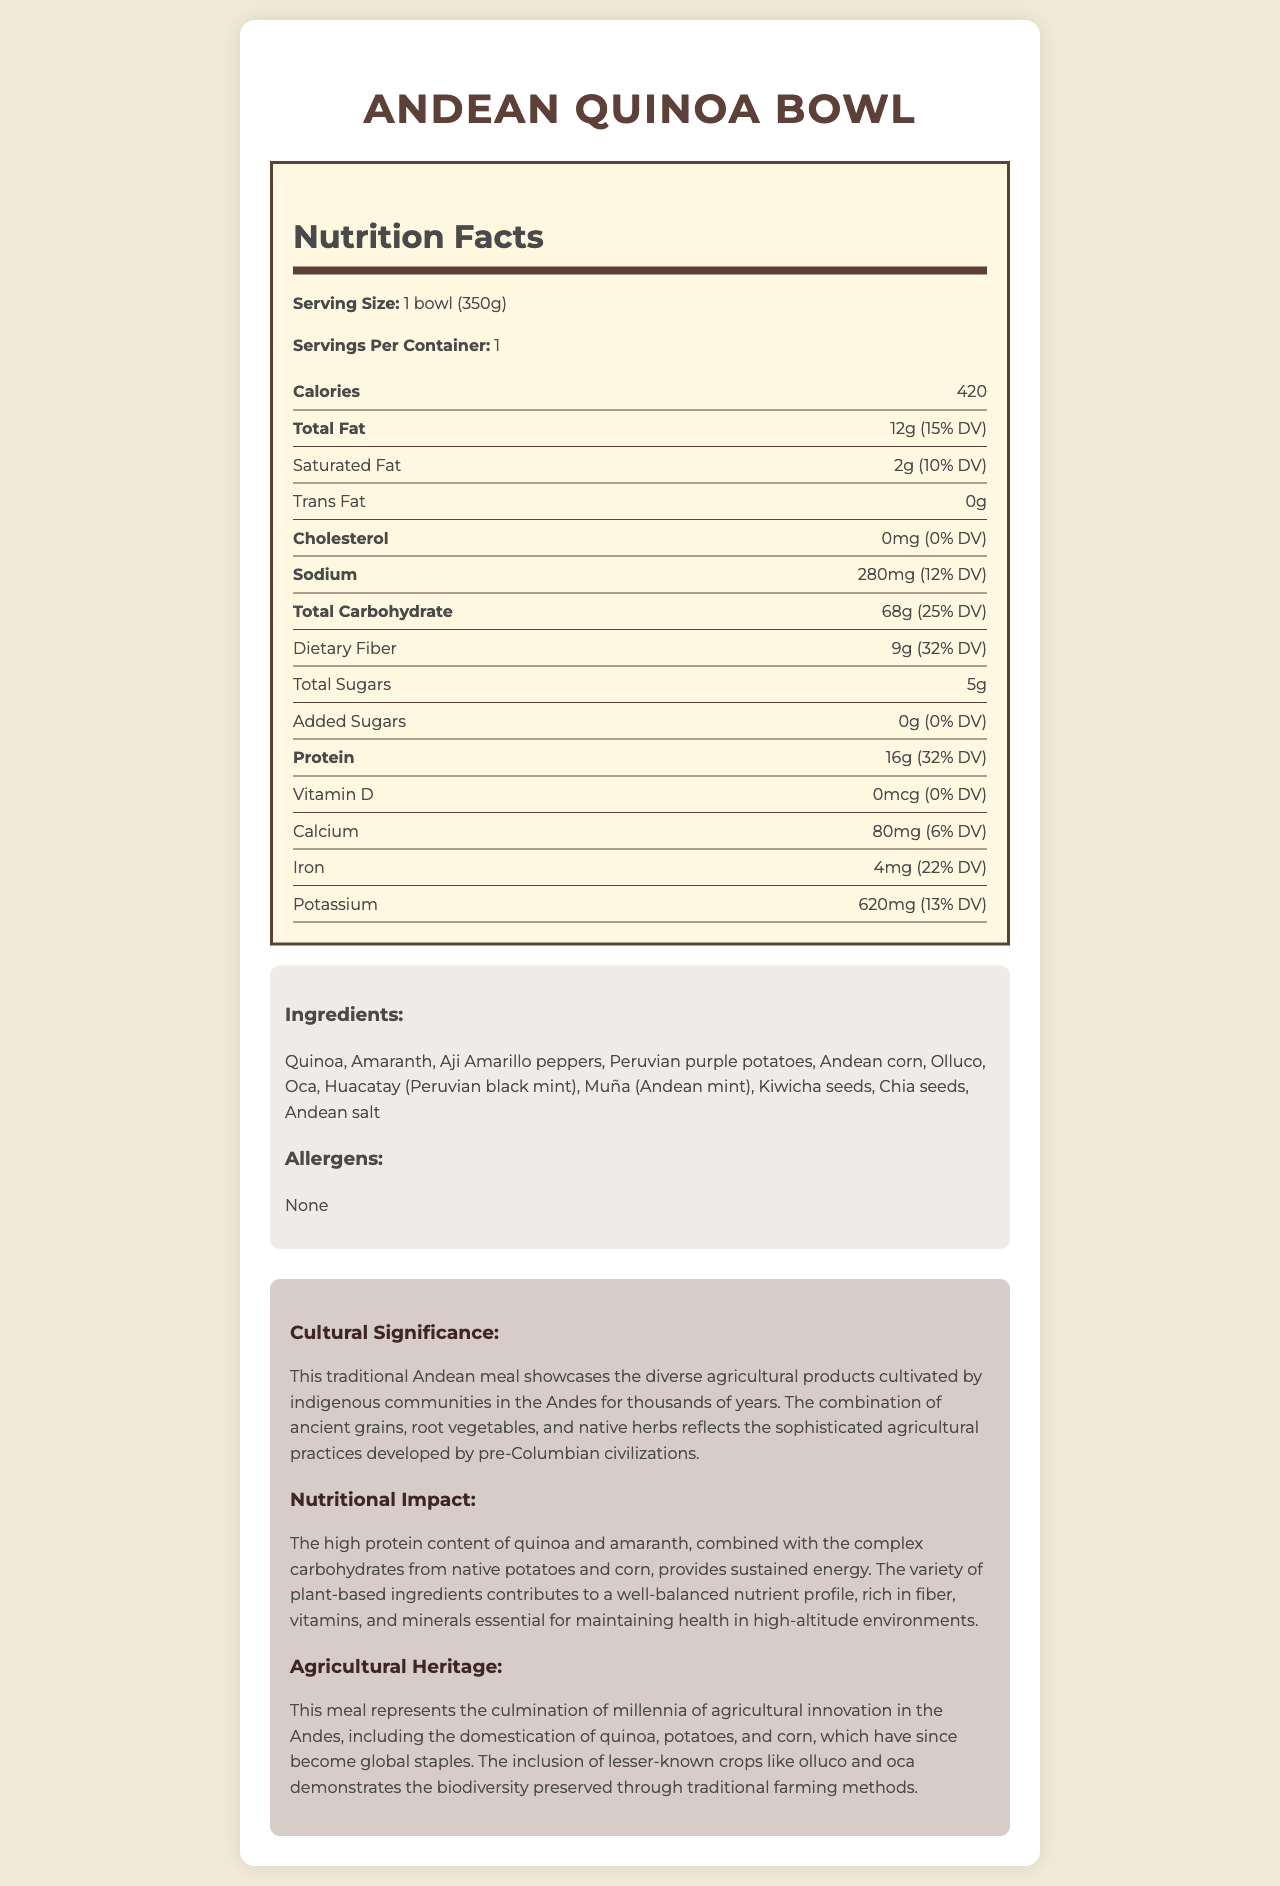what is the serving size of the Andean Quinoa Bowl? The document lists the serving size as "1 bowl (350g)" in the nutrition label section.
Answer: 1 bowl (350g) what is the total fat content per serving? The document states that the total fat content per serving is 12g.
Answer: 12g how many grams of dietary fiber does the Andean Quinoa Bowl contain? The document specifies that the dietary fiber content per serving is 9g.
Answer: 9g what is the protein content of the Andean Quinoa Bowl? The document lists the protein content per serving as 16g.
Answer: 16g what ingredient in the Andean Quinoa Bowl is also known as Peruvian black mint? The document includes Huacatay, which is specified as Peruvian black mint, in the ingredients list.
Answer: Huacatay which of the following is not an ingredient in the Andean Quinoa Bowl? A. Quinoa B. Pumpkin C. Peruvian purple potatoes D. Huacatay The document list “Pumpkin” is not in the ingredients list, unlike the other options provided.
Answer: B. Pumpkin how much sodium is in one serving? A. 12mg B. 120mg C. 280mg D. 620mg The document specifies that one serving contains 280mg of sodium.
Answer: C. 280mg does the Andean Quinoa Bowl contain any allergens according to the document? The document clearly states that there are no allergens present.
Answer: No summarize the nutritional benefits highlighted in the document. The document elaborates on the high protein content from quinoa and amaranth, the rich fiber from various ingredients, and the absence of cholesterol. It highlights how the variety of plant-based ingredients contributes to a balanced nutrient profile.
Answer: The Andean Quinoa Bowl is rich in protein, dietary fiber, and essential minerals. It has no cholesterol and contains a balanced mix of native Andean agricultural products which provide sustained energy and nutrients important for health, especially in high-altitude environments. what is the historical significance of quinoa as mentioned in the document? The document states that quinoa is an ancient grain domesticated in the Andes and has since gained importance worldwide.
Answer: Quinoa was domesticated millennia ago and has become a global staple what percentage of daily value for iron does the Andean Quinoa Bowl provide? The nutrition label in the document shows that the bowl provides 22% of the daily value for iron.
Answer: 22% what is the amount of added sugars in the Andean Quinoa Bowl? The document states that there are no added sugars in the meal.
Answer: 0g is there any information about the specific farming techniques used for these ingredients in the document? The document talks about the agricultural heritage but doesn't provide details about the specific farming techniques.
Answer: No, it does not explicitly mention the specific farming techniques. how many servings per container are indicated? The document indicates that there is 1 serving per container.
Answer: 1 describe the meal's cultural significance according to the document. The document elaborates on the meal's cultural significance by emphasizing the use of diverse Andean agricultural products and the sophisticated agricultural practices of pre-Columbian civilizations.
Answer: This traditional Andean meal showcases the diverse agricultural products cultivated by indigenous communities in the Andes for thousands of years. The combination of ancient grains, root vegetables, and native herbs reflects the sophisticated agricultural practices developed by pre-Columbian civilizations. 